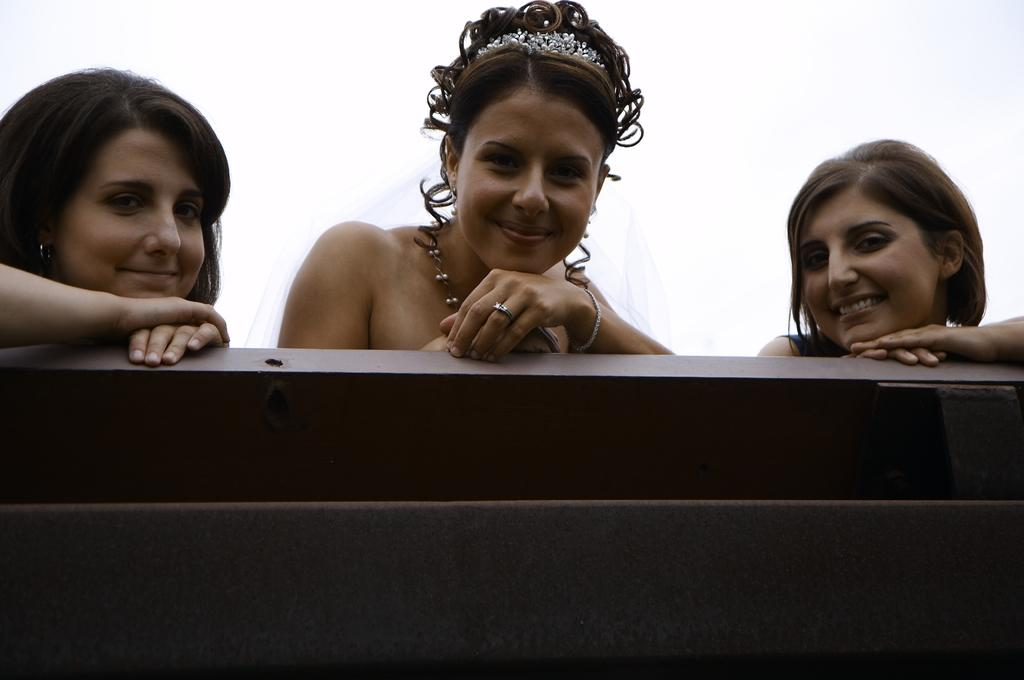What is the color of the surface in the image? The surface in the image has brown and black colors. How many women are in the image? There are three women in the image. What is the facial expression of the women? The women are smiling. What distinguishes the woman in the center from the others? The woman in the center has a crown. What color is the background of the image? The background of the image is white. What type of marble is used to decorate the ornament in the image? There is no marble or ornament present in the image. What key is being used by the women in the image? There is no key visible in the image. 